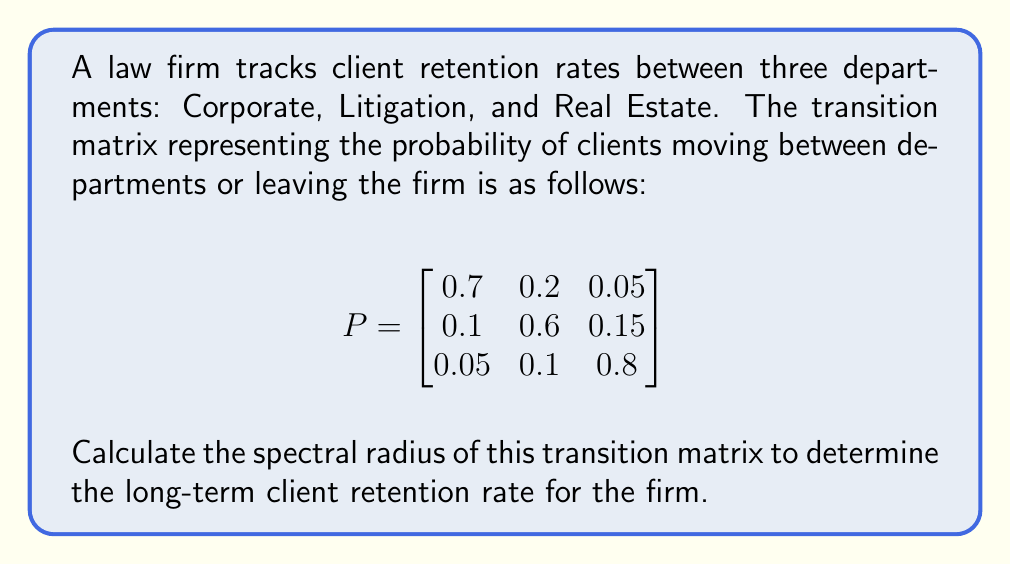Help me with this question. To calculate the spectral radius of the transition matrix, we need to follow these steps:

1. Find the characteristic equation of the matrix:
   $det(P - \lambda I) = 0$

   $$
   \begin{vmatrix}
   0.7 - \lambda & 0.2 & 0.05 \\
   0.1 & 0.6 - \lambda & 0.15 \\
   0.05 & 0.1 & 0.8 - \lambda
   \end{vmatrix} = 0
   $$

2. Expand the determinant:
   $(0.7 - \lambda)[(0.6 - \lambda)(0.8 - \lambda) - 0.015] - 0.2[0.1(0.8 - \lambda) - 0.0075] + 0.05[0.1(0.6 - \lambda) - 0.015] = 0$

3. Simplify the equation:
   $\lambda^3 - 2.1\lambda^2 + 1.41\lambda - 0.3 = 0$

4. Solve the cubic equation to find the eigenvalues. The largest eigenvalue in absolute value is the spectral radius.

5. Using a calculator or computer algebra system, we find the roots of the equation:
   $\lambda_1 \approx 1$
   $\lambda_2 \approx 0.7$
   $\lambda_3 \approx 0.4$

6. The spectral radius is the largest absolute value of the eigenvalues, which is 1.

The spectral radius of 1 indicates that the firm's long-term client retention rate is stable, as no clients are gained or lost in the long run.
Answer: $1$ 